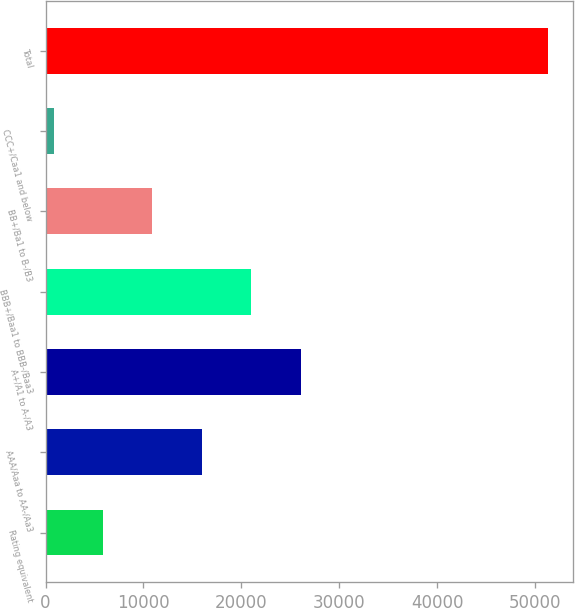Convert chart. <chart><loc_0><loc_0><loc_500><loc_500><bar_chart><fcel>Rating equivalent<fcel>AAA/Aaa to AA-/Aa3<fcel>A+/A1 to A-/A3<fcel>BBB+/Baa1 to BBB-/Baa3<fcel>BB+/Ba1 to B-/B3<fcel>CCC+/Caa1 and below<fcel>Total<nl><fcel>5876.7<fcel>15976.1<fcel>26075.5<fcel>21025.8<fcel>10926.4<fcel>827<fcel>51324<nl></chart> 